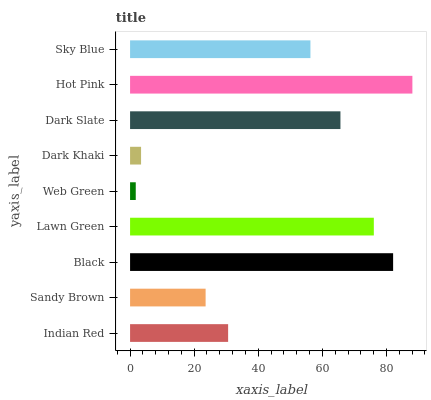Is Web Green the minimum?
Answer yes or no. Yes. Is Hot Pink the maximum?
Answer yes or no. Yes. Is Sandy Brown the minimum?
Answer yes or no. No. Is Sandy Brown the maximum?
Answer yes or no. No. Is Indian Red greater than Sandy Brown?
Answer yes or no. Yes. Is Sandy Brown less than Indian Red?
Answer yes or no. Yes. Is Sandy Brown greater than Indian Red?
Answer yes or no. No. Is Indian Red less than Sandy Brown?
Answer yes or no. No. Is Sky Blue the high median?
Answer yes or no. Yes. Is Sky Blue the low median?
Answer yes or no. Yes. Is Dark Slate the high median?
Answer yes or no. No. Is Dark Khaki the low median?
Answer yes or no. No. 